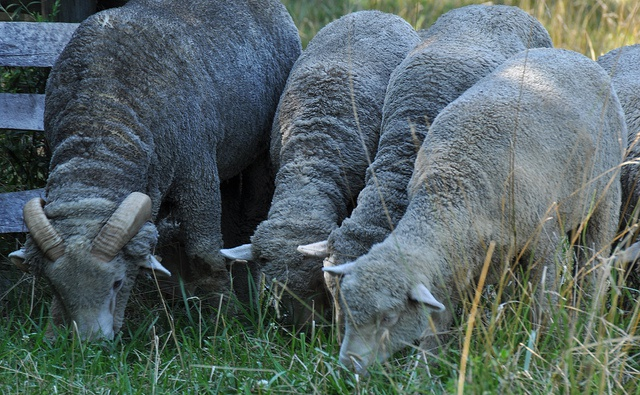Describe the objects in this image and their specific colors. I can see sheep in black, gray, and darkgray tones, sheep in black, gray, and blue tones, sheep in black and gray tones, sheep in black, gray, and darkgray tones, and sheep in black, darkgray, and gray tones in this image. 